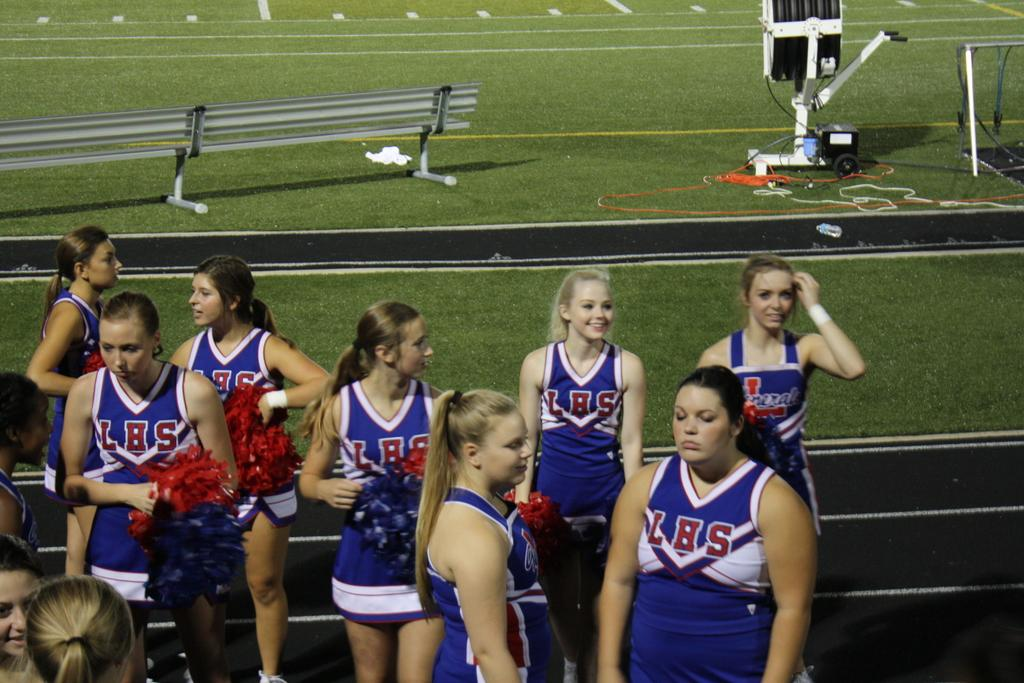<image>
Relay a brief, clear account of the picture shown. The eight cheer leaders shown in the picture are from LHS. 